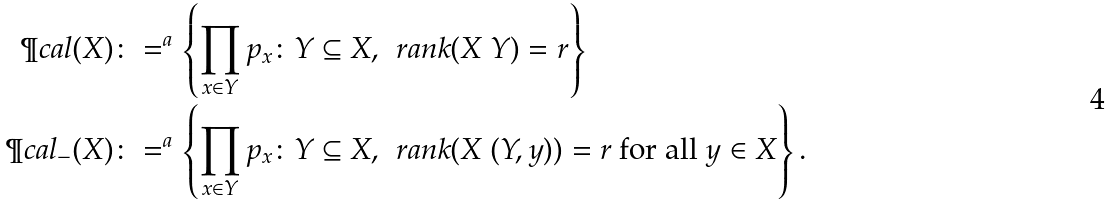Convert formula to latex. <formula><loc_0><loc_0><loc_500><loc_500>\P c a l ( X ) & \colon = ^ { a } \left \{ \prod _ { x \in Y } p _ { x } \colon Y \subseteq X , \, \ r a n k ( X \ Y ) = r \right \} \\ \P c a l _ { - } ( X ) & \colon = ^ { a } \left \{ \prod _ { x \in Y } p _ { x } \colon Y \subseteq X , \, \ r a n k ( X \ ( Y , y ) ) = r \text { for all } y \in X \right \} .</formula> 